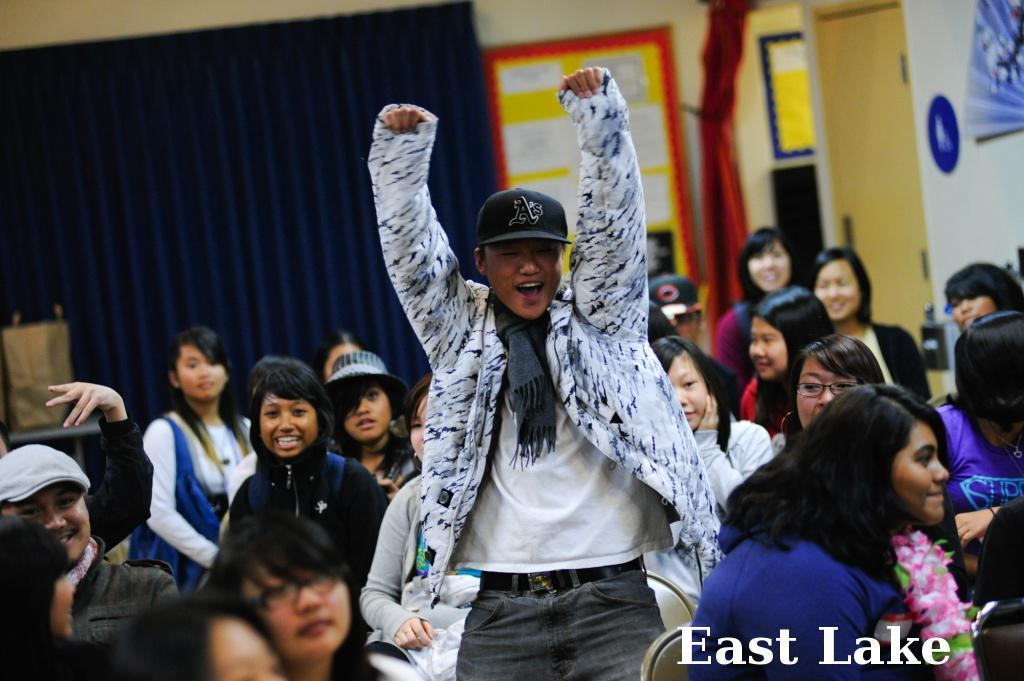What is happening in the image? There are many girls sitting on chairs, and a man is standing in the middle of the image. Can you describe the man's attire? The man is wearing a jacket, scarf, and cap. What can be seen in the background of the image? There is a curtain and a banner on the wall in the background. Can you tell me how deep the river is in the image? There is no river present in the image. What type of yard can be seen in the image? There is no yard visible in the image. 